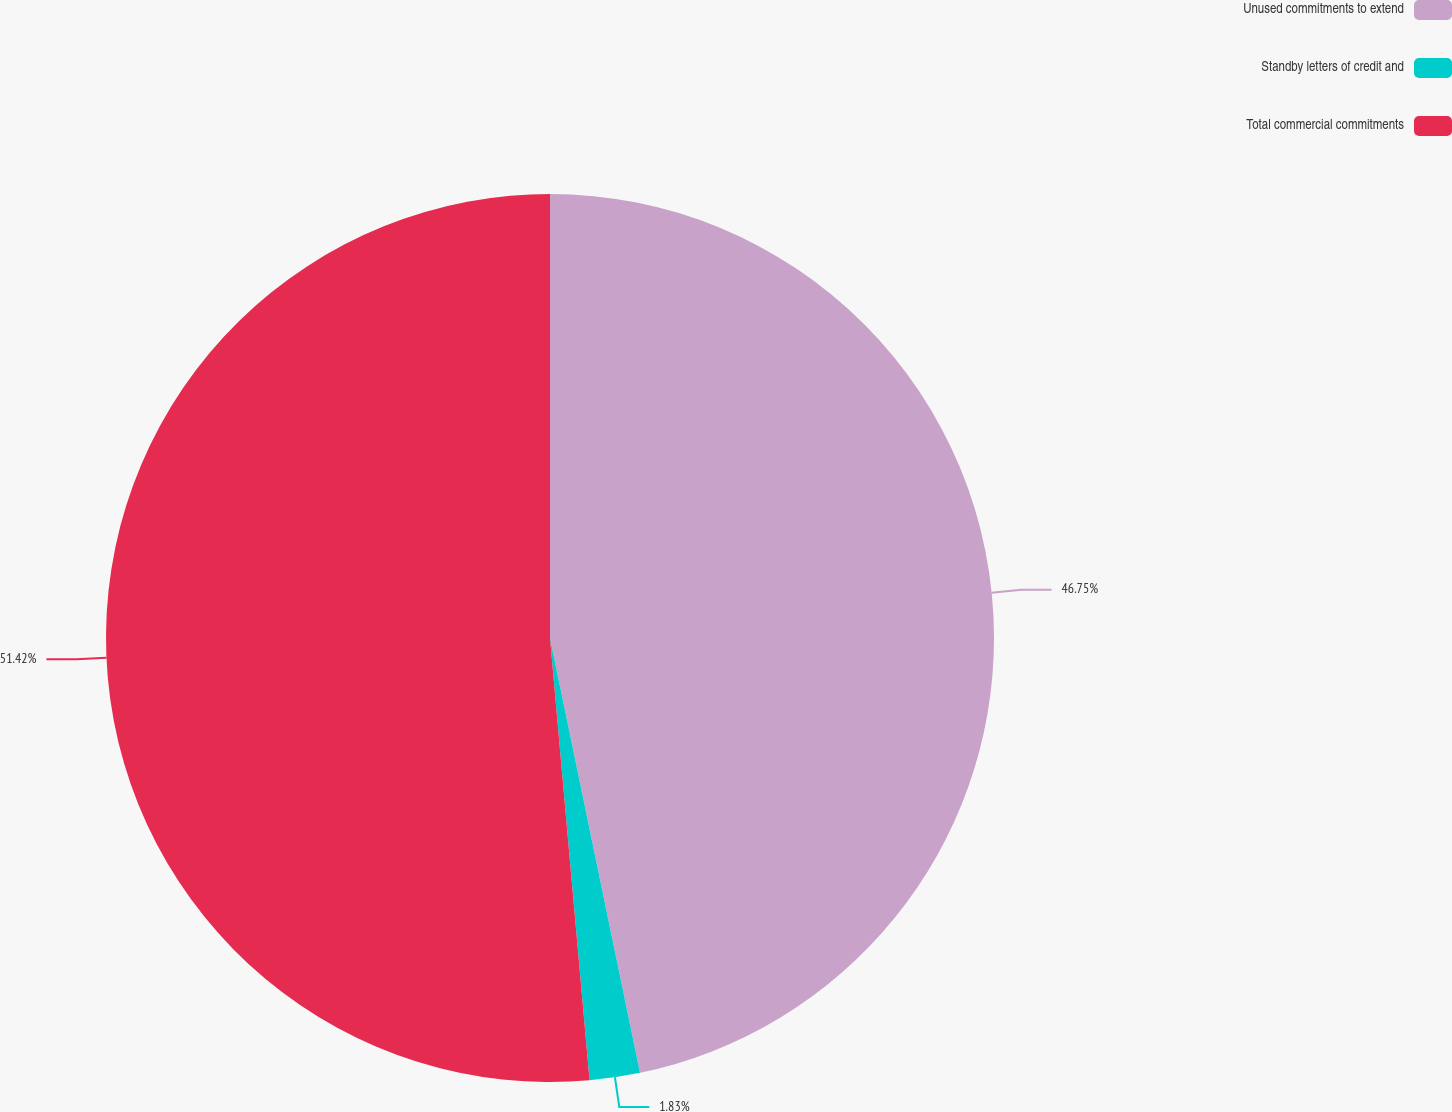<chart> <loc_0><loc_0><loc_500><loc_500><pie_chart><fcel>Unused commitments to extend<fcel>Standby letters of credit and<fcel>Total commercial commitments<nl><fcel>46.75%<fcel>1.83%<fcel>51.42%<nl></chart> 